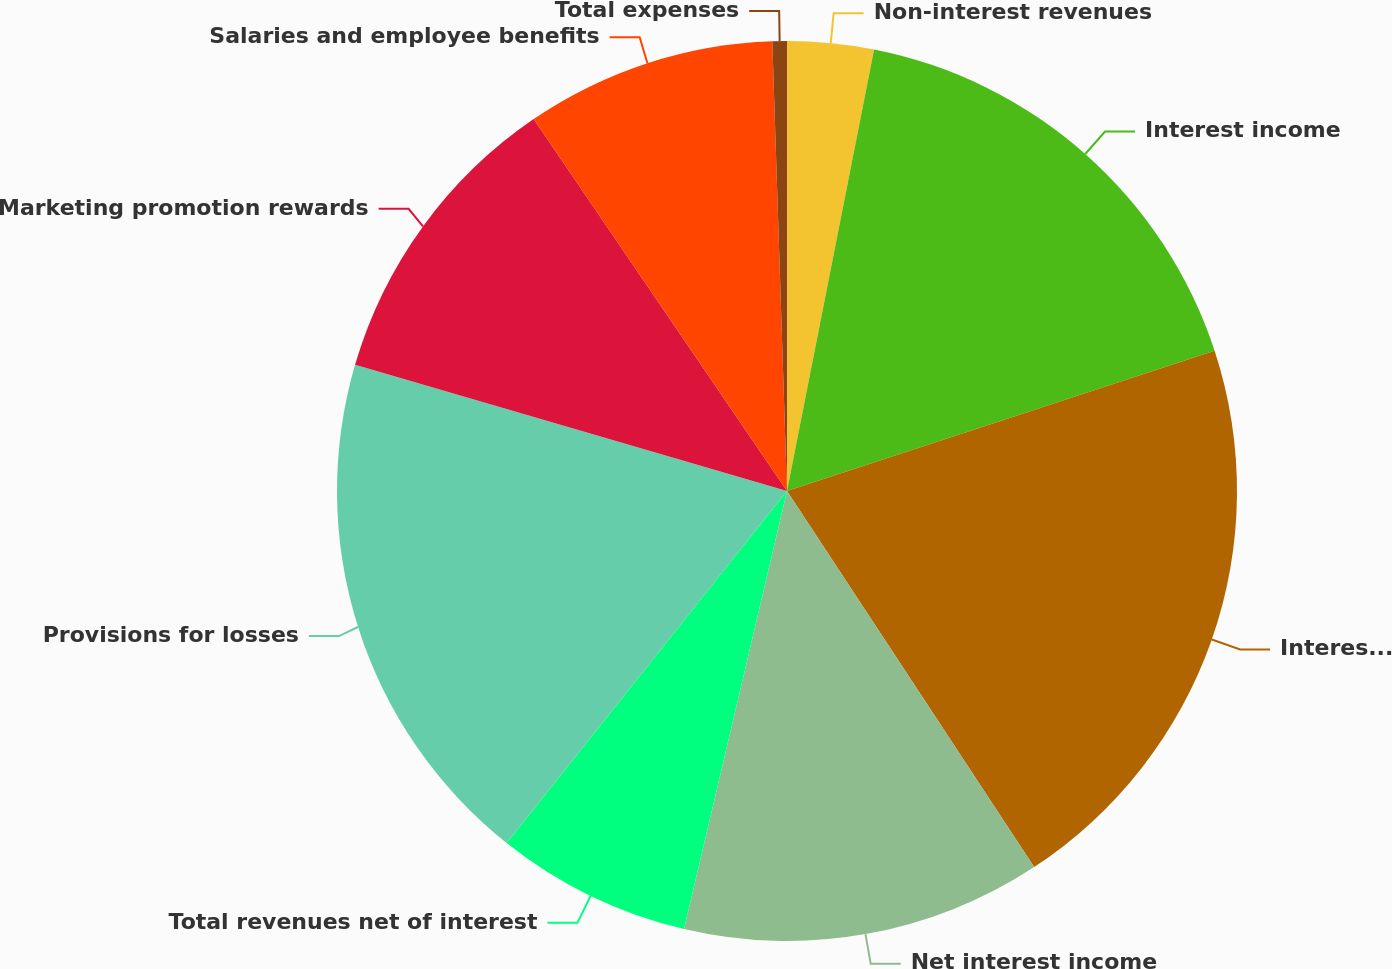<chart> <loc_0><loc_0><loc_500><loc_500><pie_chart><fcel>Non-interest revenues<fcel>Interest income<fcel>Interest expense<fcel>Net interest income<fcel>Total revenues net of interest<fcel>Provisions for losses<fcel>Marketing promotion rewards<fcel>Salaries and employee benefits<fcel>Total expenses<nl><fcel>3.1%<fcel>16.86%<fcel>20.79%<fcel>12.93%<fcel>7.03%<fcel>18.82%<fcel>10.96%<fcel>9.0%<fcel>0.52%<nl></chart> 